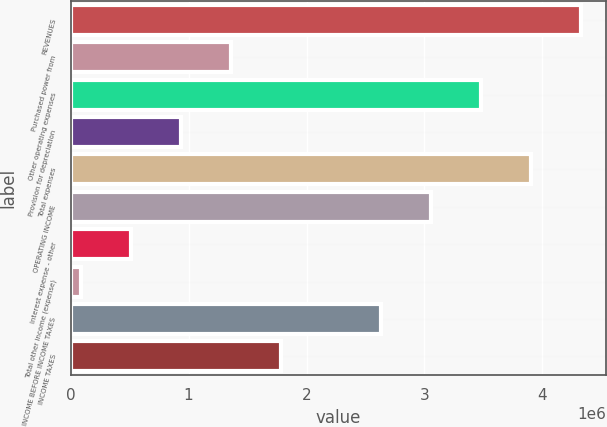<chart> <loc_0><loc_0><loc_500><loc_500><bar_chart><fcel>REVENUES<fcel>Purchased power from<fcel>Other operating expenses<fcel>Provision for depreciation<fcel>Total expenses<fcel>OPERATING INCOME<fcel>Interest expense - other<fcel>Total other income (expense)<fcel>INCOME BEFORE INCOME TAXES<fcel>INCOME TAXES<nl><fcel>4.32503e+06<fcel>1.35723e+06<fcel>3.47708e+06<fcel>933258<fcel>3.90106e+06<fcel>3.05311e+06<fcel>509287<fcel>85316<fcel>2.62914e+06<fcel>1.7812e+06<nl></chart> 